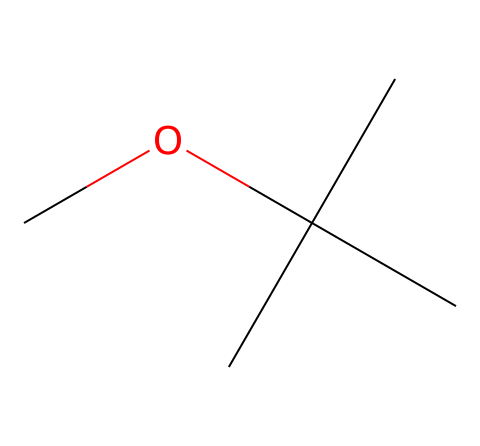What is the molecular formula of MTBE? To determine the molecular formula, analyze the SMILES representation: COC(C)(C)C shows two carbon atoms in the ether part, and additional carbon atoms in the tert-butyl group. The total count results in a formula C5H12O.
Answer: C5H12O How many carbon atoms does MTBE contain? From the SMILES notation, there are 5 carbon atoms visible: one in the ether part and four in the tert-butyl group.
Answer: 5 What type of chemical compound is MTBE? Based on its structure and functional group, specifically the presence of an ether (C-O-C) bond, it is classified as an ether.
Answer: ether What is the total number of hydrogen atoms in MTBE? Count the hydrogen atoms by reviewing the connections: There are 12 hydrogen atoms attached to the five carbon atoms in the structure.
Answer: 12 What would happen to MTBE upon combustion? When MTBE combusts, it typically produces carbon dioxide and water, a common result of hydrocarbon combustion.
Answer: carbon dioxide and water How would the presence of MTBE affect octane ratings in fuel? MTBE is recognized as an octane booster, which enhances fuel performance by increasing the octane rating and reducing knocking in combustion engines.
Answer: increases octane rating What is the role of the ether group in MTBE? The ether group (R-O-R) contributes to the chemical’s volatility and solubility properties, which are crucial for its function as a fuel additive.
Answer: volatility and solubility 